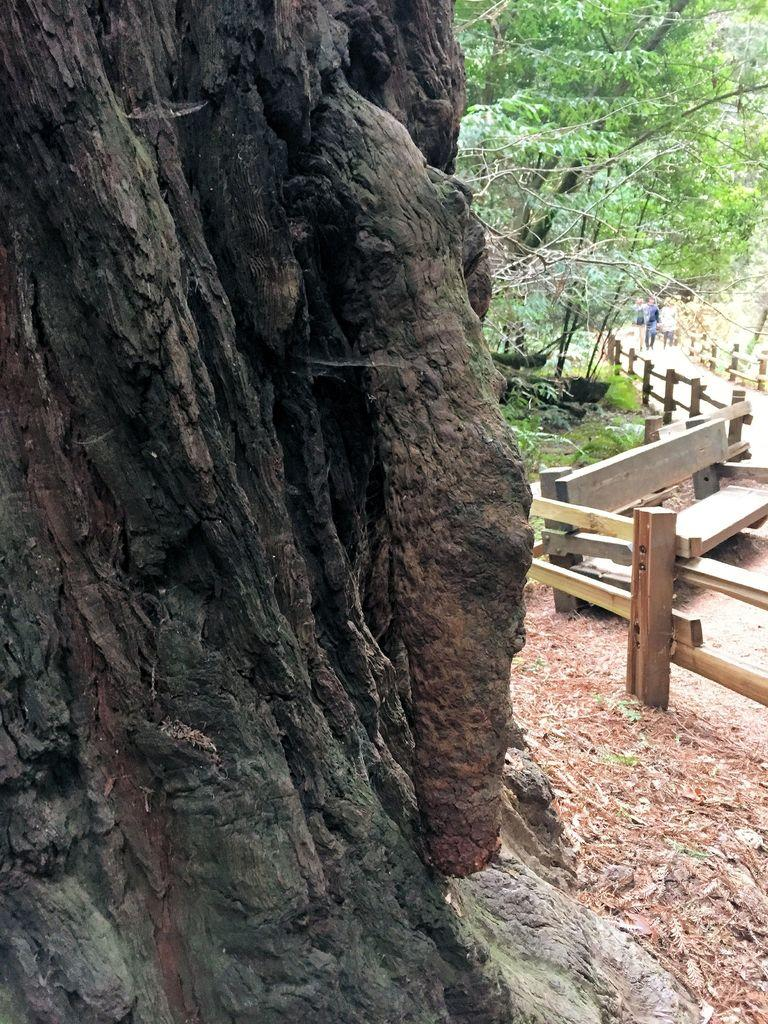What is the main object in the image? There is a tree trunk in the image. What is located on the ground near the tree trunk? There is a bench on the ground in the image. What type of structure can be seen in the image? There are fences in the image. What type of vegetation is present in the image? There are trees and grass in the image. What can be seen in the image that indicates human presence? There are people on a path in the image. How many beds are visible in the image? There are no beds present in the image. What type of wish can be granted by the tree in the image? There is no mention of wishes or magical abilities in the image; it simply features a tree trunk and other objects. 